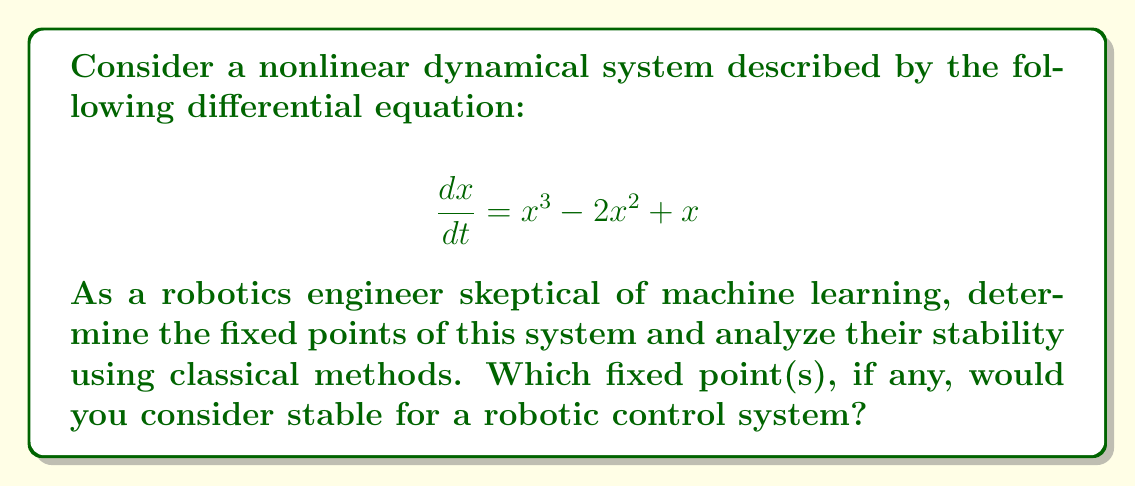Could you help me with this problem? Let's approach this step-by-step:

1) First, we need to find the fixed points. These occur when $\frac{dx}{dt} = 0$. So, we solve:

   $$x^3 - 2x^2 + x = 0$$

2) Factor out x:
   
   $$x(x^2 - 2x + 1) = 0$$

3) Solve this equation:
   $x = 0$ or $x^2 - 2x + 1 = 0$
   
   Using the quadratic formula for the second part:
   $x = \frac{2 \pm \sqrt{4-4}}{2} = 1$

   So, the fixed points are $x = 0$ and $x = 1$.

4) To analyze stability, we need to look at the derivative of the right-hand side of the original equation at each fixed point:

   $$\frac{d}{dx}(x^3 - 2x^2 + x) = 3x^2 - 4x + 1$$

5) Evaluate this at each fixed point:

   At $x = 0$: $3(0)^2 - 4(0) + 1 = 1$
   At $x = 1$: $3(1)^2 - 4(1) + 1 = 0$

6) Interpret these results:
   - For $x = 0$, the derivative is positive (1), indicating an unstable fixed point.
   - For $x = 1$, the derivative is zero (0), indicating a non-hyperbolic fixed point.

7) For the non-hyperbolic point at $x = 1$, we need to look at higher-order terms:
   Near $x = 1$, let $x = 1 + \epsilon$
   
   $$\frac{d\epsilon}{dt} = (1+\epsilon)^3 - 2(1+\epsilon)^2 + (1+\epsilon) - 1$$
   
   Expanding and simplifying:
   
   $$\frac{d\epsilon}{dt} = \epsilon^3 - \epsilon^2$$
   
   For small $\epsilon$, $\epsilon^3 < \epsilon^2$, so $\frac{d\epsilon}{dt} < 0$, indicating stability.

8) From a robotics engineering perspective, the fixed point at $x = 1$ would be considered stable and suitable for a control system. The fixed point at $x = 0$ is unstable and would be problematic for maintaining a desired state in a robotic system.
Answer: $x = 1$ is stable; $x = 0$ is unstable. 